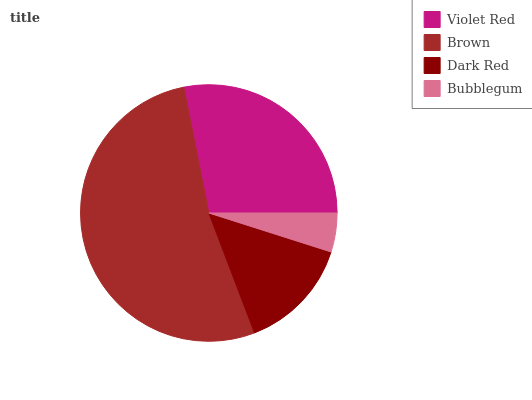Is Bubblegum the minimum?
Answer yes or no. Yes. Is Brown the maximum?
Answer yes or no. Yes. Is Dark Red the minimum?
Answer yes or no. No. Is Dark Red the maximum?
Answer yes or no. No. Is Brown greater than Dark Red?
Answer yes or no. Yes. Is Dark Red less than Brown?
Answer yes or no. Yes. Is Dark Red greater than Brown?
Answer yes or no. No. Is Brown less than Dark Red?
Answer yes or no. No. Is Violet Red the high median?
Answer yes or no. Yes. Is Dark Red the low median?
Answer yes or no. Yes. Is Bubblegum the high median?
Answer yes or no. No. Is Violet Red the low median?
Answer yes or no. No. 